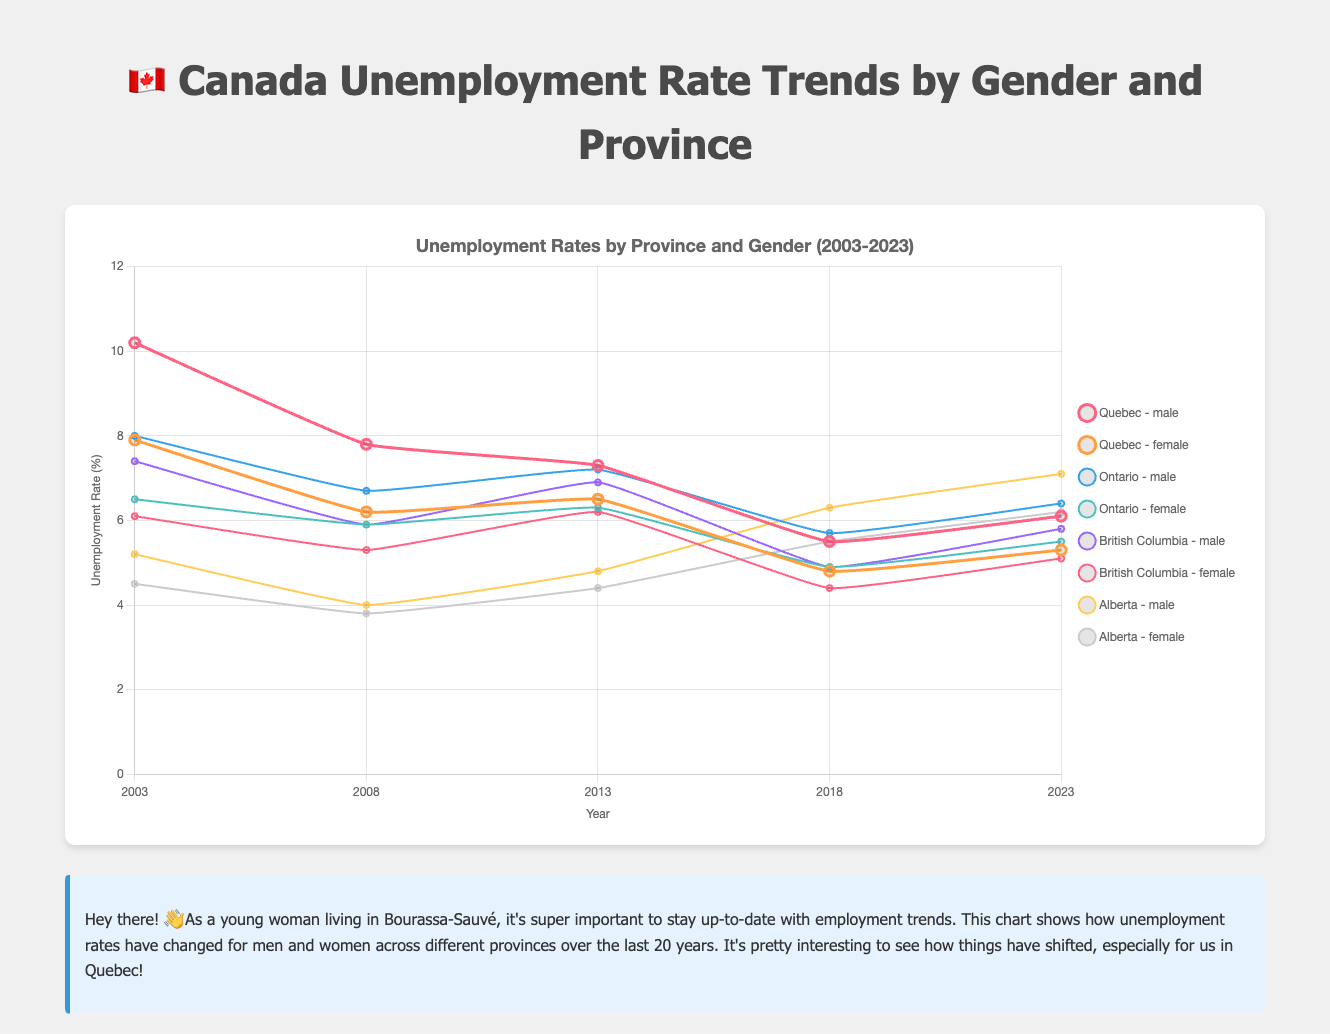What was the trend in the male unemployment rate in Quebec from 2003 to 2018? To determine the trend, observe the changes in the male unemployment rate in Quebec over the years 2003 (10.2%), 2008 (7.8%), 2013 (7.3%), and 2018 (5.5%). There is a consistent decrease over these years.
Answer: Decreasing Compare the female unemployment rate in Quebec and Ontario in 2023. Which province had the lower rate? In 2023, the female unemployment rate in Quebec was 5.3%, and in Ontario, it was 5.5%. Quebec had a lower rate.
Answer: Quebec Which province had the highest male unemployment rate in 2003? Look at the male unemployment rates for each province in 2003: Quebec (10.2%), Ontario (8.0%), British Columbia (7.4%), and Alberta (5.2%). Quebec had the highest rate.
Answer: Quebec How did the female unemployment rate in Alberta change from 2008 to 2023? Observe the female unemployment rates in Alberta: 2008 (3.8%), 2013 (4.4%), 2018 (5.5%), and 2023 (6.2%). The rate increased over these years.
Answer: Increased What was the average male unemployment rate in British Columbia from 2003 to 2023? The male unemployment rates in British Columbia are 7.4% (2003), 5.9% (2008), 6.9% (2013), 4.9% (2018), and 5.8% (2023). Sum these rates: 7.4 + 5.9 + 6.9 + 4.9 + 5.8 = 30.9. The average is 30.9 / 5.
Answer: 6.18% Between Ontario and Alberta, which province experienced a larger increase in male unemployment rate from 2018 to 2023? Compare the increase in male unemployment rates: Ontario (5.7% to 6.4%, an increase of 0.7%) and Alberta (6.3% to 7.1%, an increase of 0.8%). Alberta experienced a larger increase.
Answer: Alberta What is the difference in the Quebec male unemployment rate from 2003 to 2023? The male unemployment rates in Quebec were 10.2% in 2003 and 6.1% in 2023. The difference is 10.2 - 6.1.
Answer: 4.1% How did the unemployment rates for females in Quebec compare to males in Quebec in 2018? In 2018, the female unemployment rate in Quebec was 4.8% and the male rate was 5.5%. The female rate was lower.
Answer: Female rate was lower Which year had the lowest overall male unemployment rate across all provinces? Find the lowest male unemployment rate from the given data: the values are 10.2%, 7.8%, 7.3%, 5.5%, 6.1%, 8.0%, 6.7%, 7.2%, 5.7%, 6.4%, 7.4%, 5.9%, 6.9%, 4.9%, 5.8%, 5.2%, 4.0%, 4.8%, 6.3%, 7.1%. The lowest is in Alberta, 2008 at 4.0%.
Answer: 2008 (Alberta) How does the trend in the female unemployment rate in British Columbia compare from 2003 to 2023? The female unemployment rates in British Columbia are 6.1% (2003), 5.3% (2008), 6.2% (2013), 4.4% (2018), and 5.1% (2023). This shows a general decrease with minimal fluctuations.
Answer: Decreasing with fluctuations 